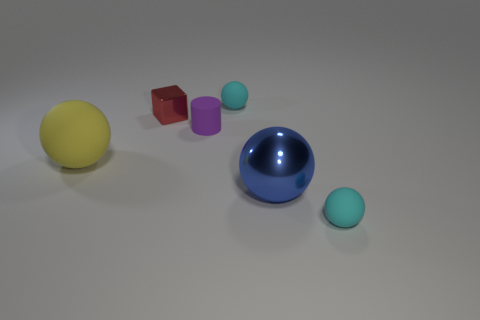Subtract all purple balls. Subtract all blue blocks. How many balls are left? 4 Add 3 cyan spheres. How many objects exist? 9 Subtract all blocks. How many objects are left? 5 Subtract 0 gray cylinders. How many objects are left? 6 Subtract all tiny green matte cylinders. Subtract all purple rubber cylinders. How many objects are left? 5 Add 1 red cubes. How many red cubes are left? 2 Add 1 yellow balls. How many yellow balls exist? 2 